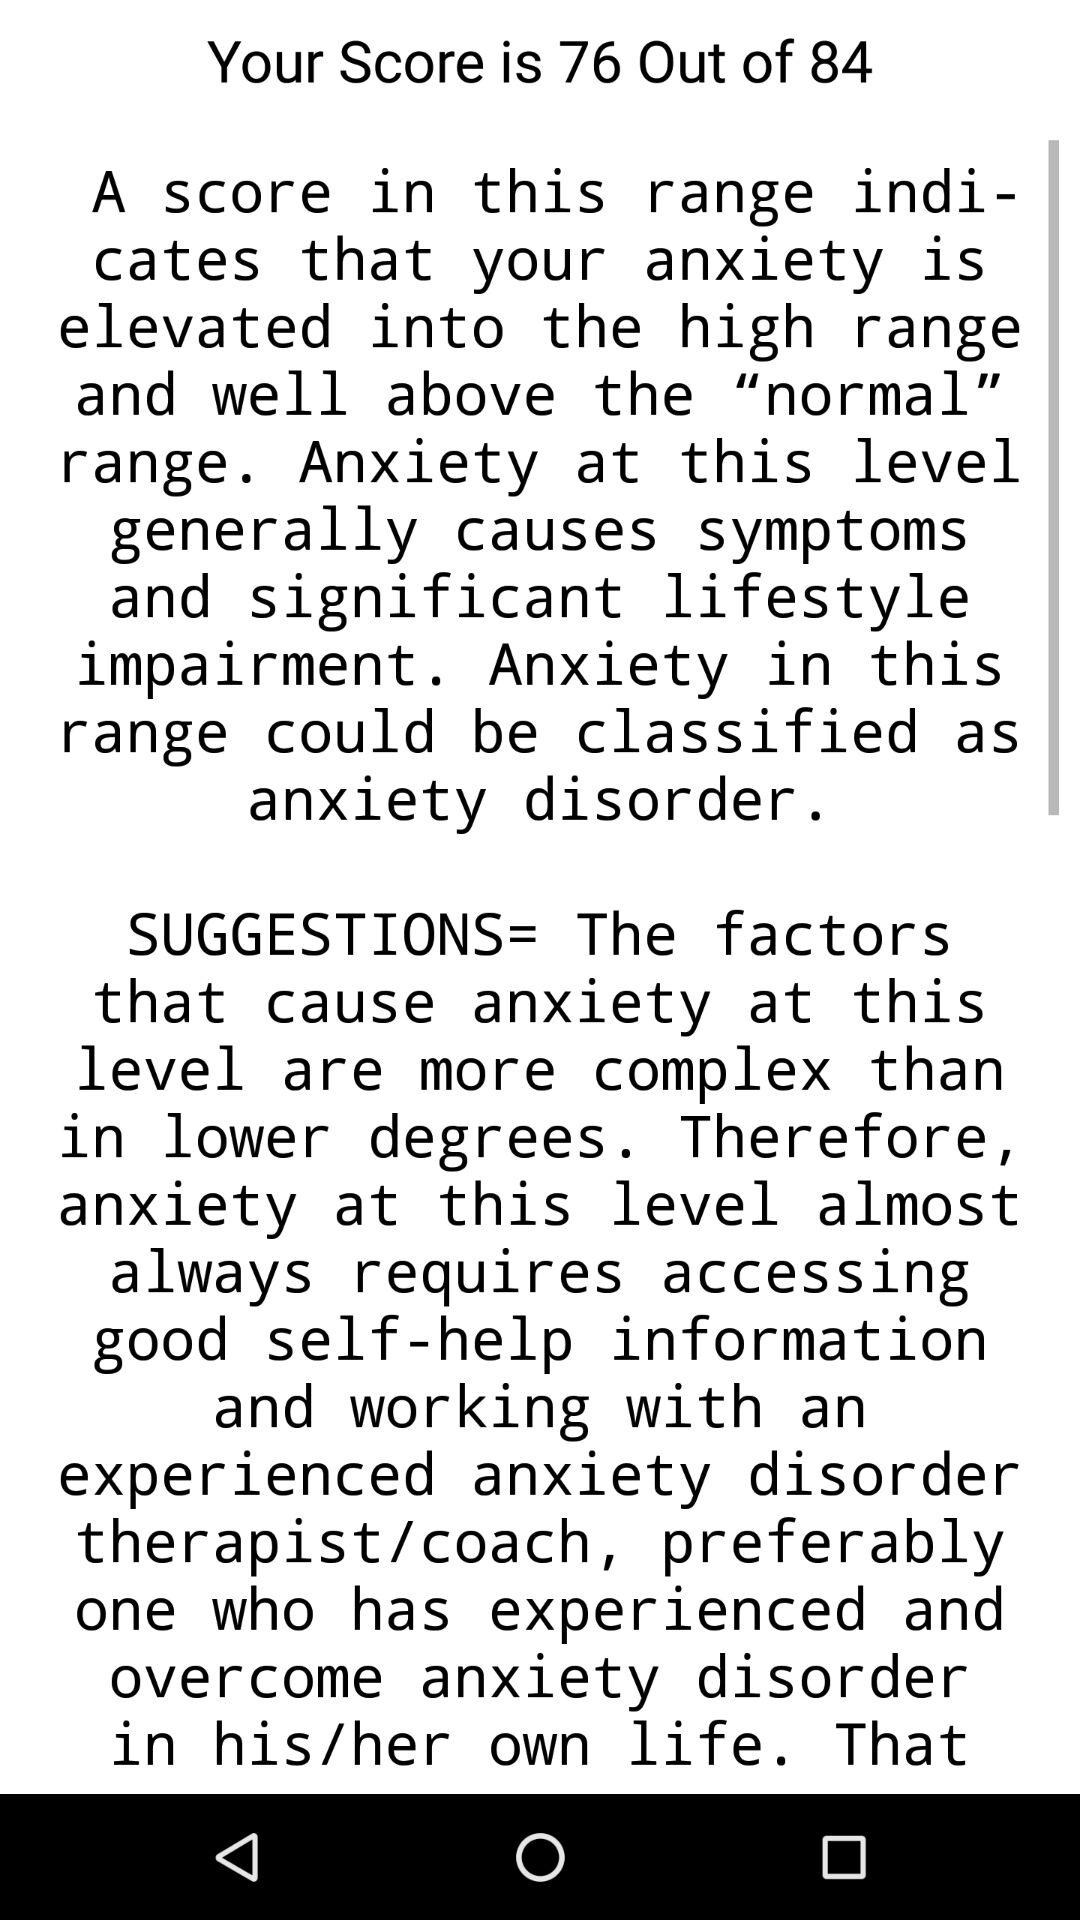What is the score? The score is 76. 